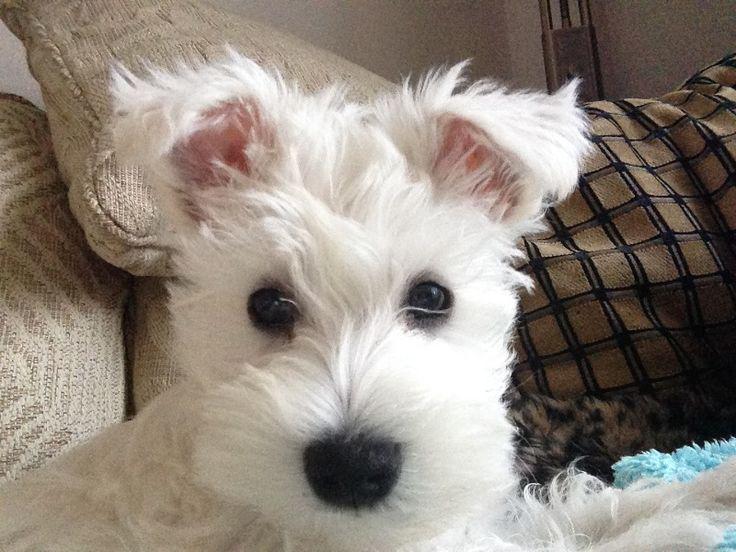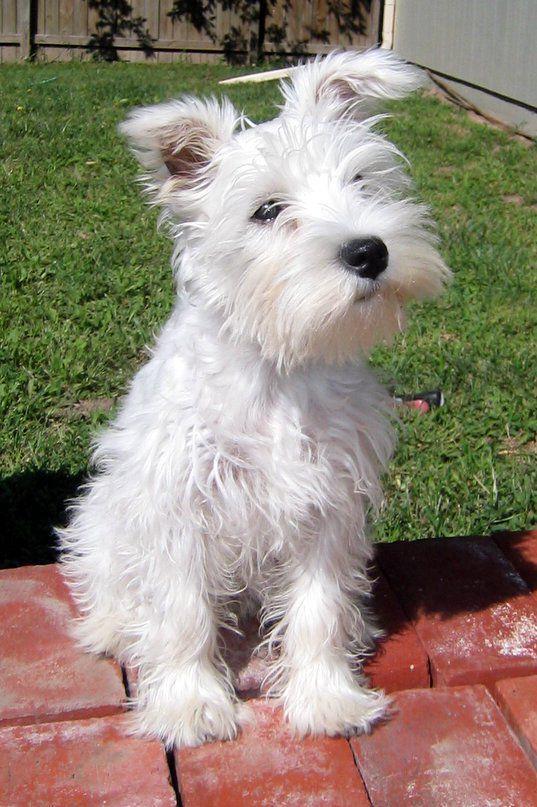The first image is the image on the left, the second image is the image on the right. For the images shown, is this caption "There is a dog on grass in one of the iamges" true? Answer yes or no. No. 